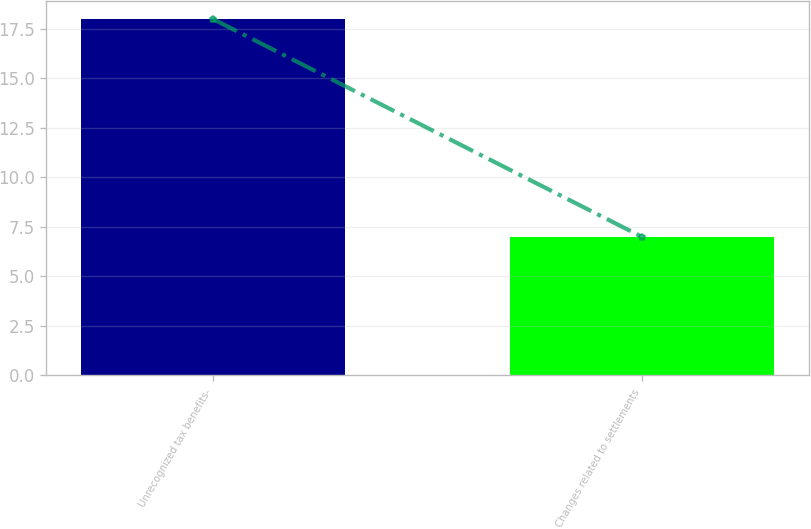Convert chart. <chart><loc_0><loc_0><loc_500><loc_500><bar_chart><fcel>Unrecognized tax benefits-<fcel>Changes related to settlements<nl><fcel>18<fcel>7<nl></chart> 